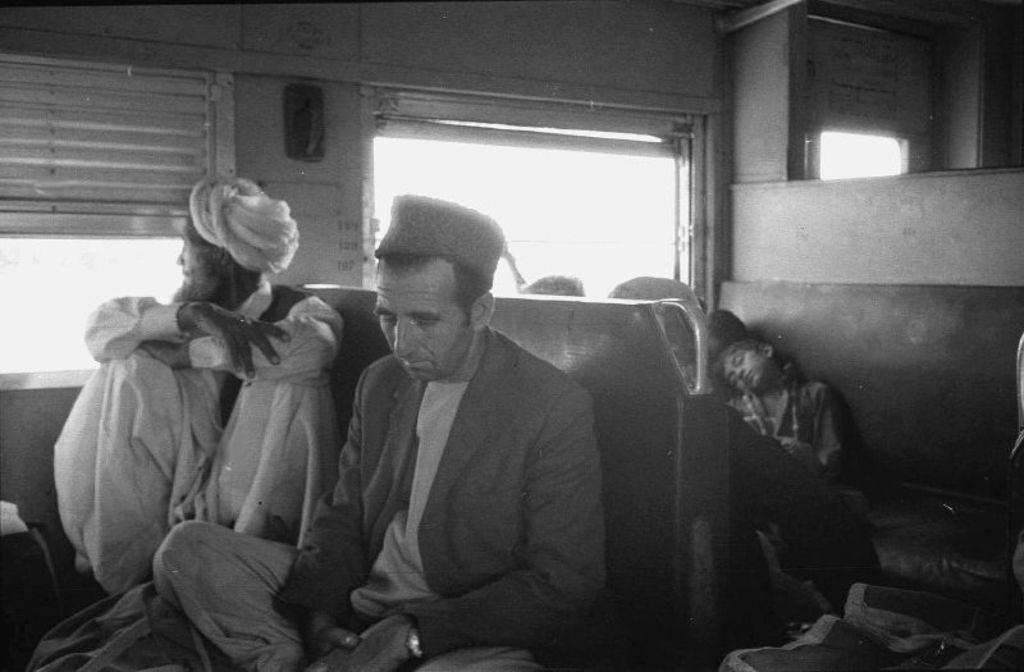What is the color scheme of the image? The image is black and white. Where does it seem the image was taken? The image appears to be taken inside a train. What can be seen in the image besides the train interior? There are passengers sitting on seats in the image. What might provide a view of the outside while inside the train? There are windows visible behind the passengers. Can you see any tails in the image? There are no tails present in the image. What type of jail is depicted in the image? There is no jail depicted in the image; it is a black and white photograph taken inside a train. 